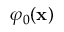Convert formula to latex. <formula><loc_0><loc_0><loc_500><loc_500>\varphi _ { 0 } ( x )</formula> 